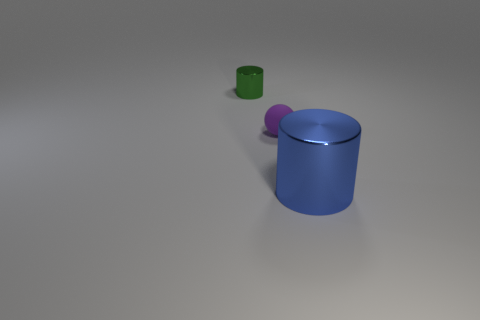Add 2 large blue metal blocks. How many objects exist? 5 Subtract all balls. How many objects are left? 2 Subtract all tiny purple matte things. Subtract all big red metal spheres. How many objects are left? 2 Add 1 purple matte objects. How many purple matte objects are left? 2 Add 2 tiny rubber spheres. How many tiny rubber spheres exist? 3 Subtract 0 red balls. How many objects are left? 3 